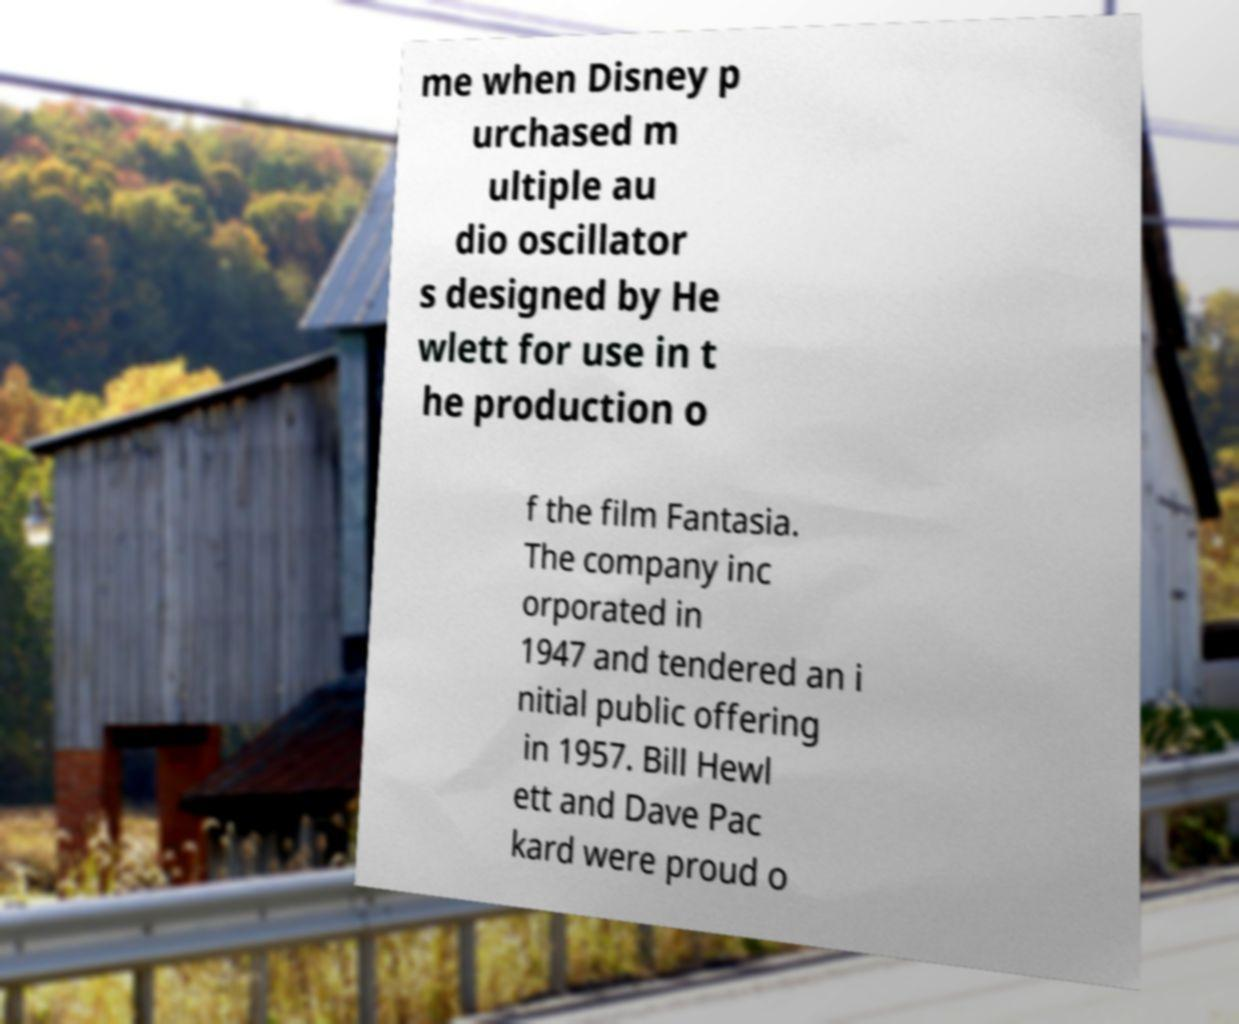I need the written content from this picture converted into text. Can you do that? me when Disney p urchased m ultiple au dio oscillator s designed by He wlett for use in t he production o f the film Fantasia. The company inc orporated in 1947 and tendered an i nitial public offering in 1957. Bill Hewl ett and Dave Pac kard were proud o 